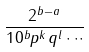Convert formula to latex. <formula><loc_0><loc_0><loc_500><loc_500>\frac { 2 ^ { b - a } } { 1 0 ^ { b } p ^ { k } q ^ { l } \cdot \cdot \cdot }</formula> 